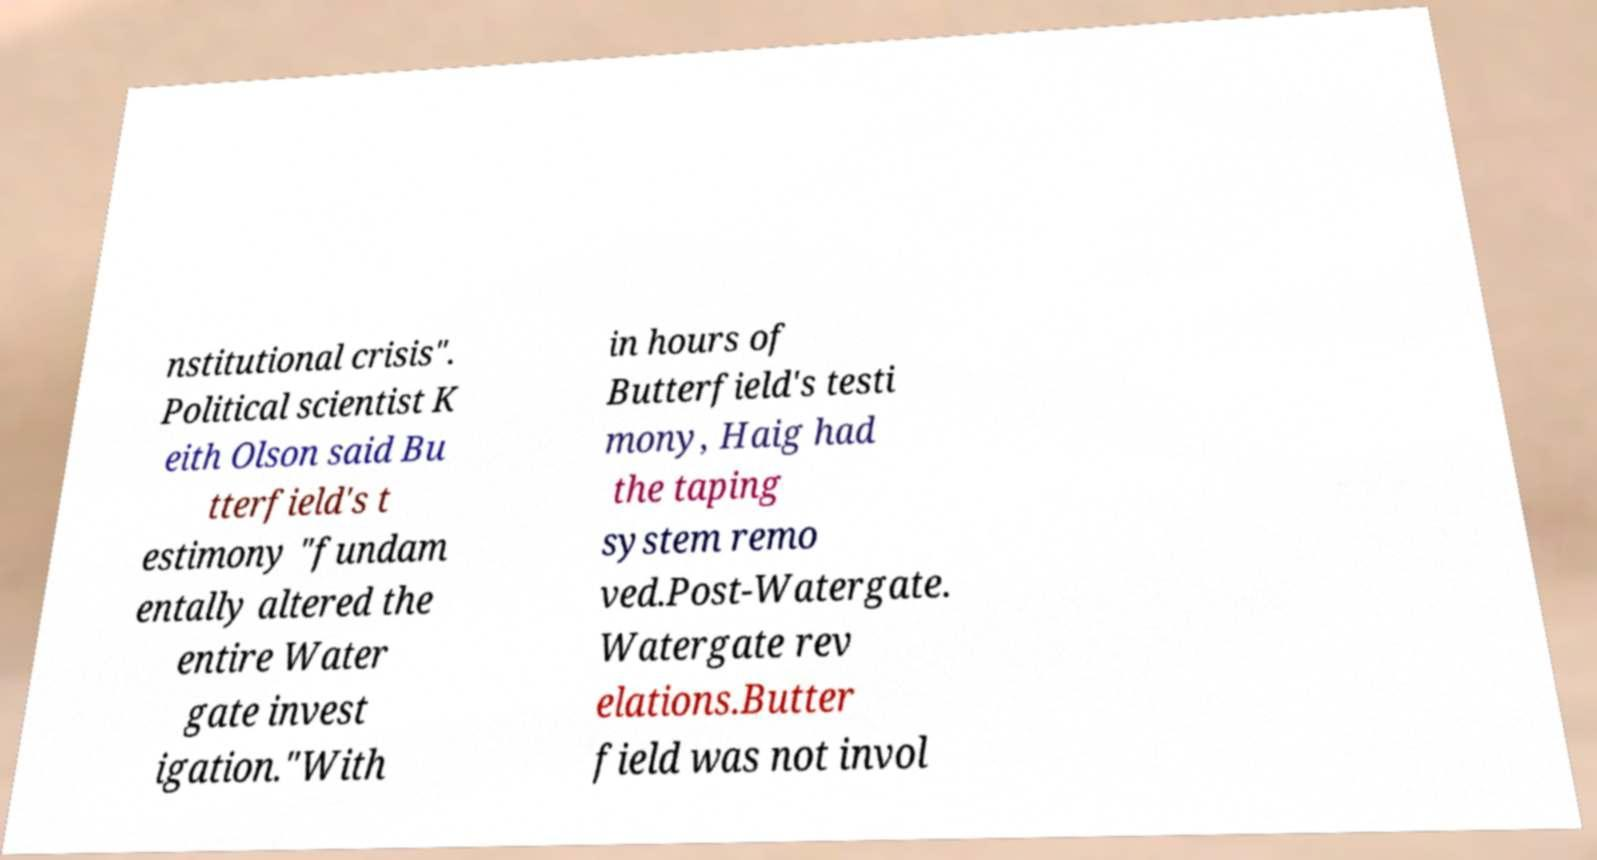For documentation purposes, I need the text within this image transcribed. Could you provide that? nstitutional crisis". Political scientist K eith Olson said Bu tterfield's t estimony "fundam entally altered the entire Water gate invest igation."With in hours of Butterfield's testi mony, Haig had the taping system remo ved.Post-Watergate. Watergate rev elations.Butter field was not invol 